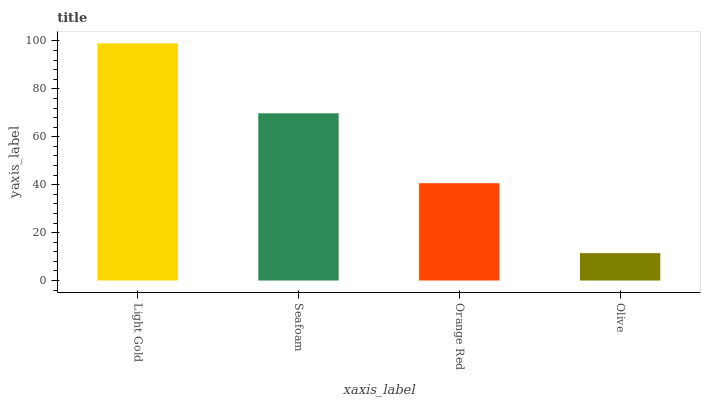Is Olive the minimum?
Answer yes or no. Yes. Is Light Gold the maximum?
Answer yes or no. Yes. Is Seafoam the minimum?
Answer yes or no. No. Is Seafoam the maximum?
Answer yes or no. No. Is Light Gold greater than Seafoam?
Answer yes or no. Yes. Is Seafoam less than Light Gold?
Answer yes or no. Yes. Is Seafoam greater than Light Gold?
Answer yes or no. No. Is Light Gold less than Seafoam?
Answer yes or no. No. Is Seafoam the high median?
Answer yes or no. Yes. Is Orange Red the low median?
Answer yes or no. Yes. Is Light Gold the high median?
Answer yes or no. No. Is Olive the low median?
Answer yes or no. No. 